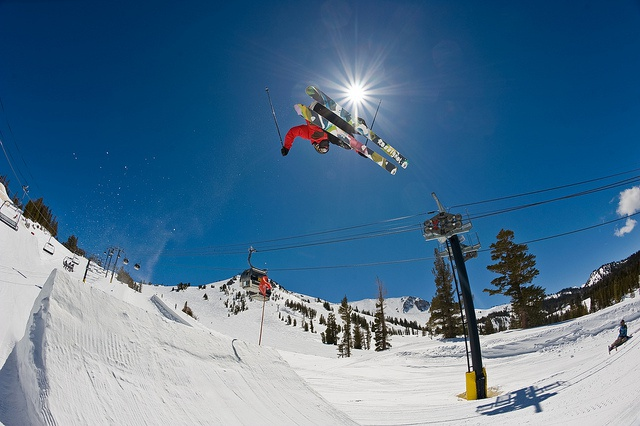Describe the objects in this image and their specific colors. I can see skis in navy, gray, lightgray, darkgray, and black tones, people in navy, brown, black, and gray tones, people in navy, black, gray, and blue tones, and people in navy and black tones in this image. 